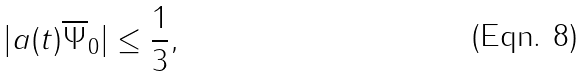Convert formula to latex. <formula><loc_0><loc_0><loc_500><loc_500>| a ( t ) \overline { \Psi } _ { 0 } | \leq \frac { 1 } { 3 } ,</formula> 